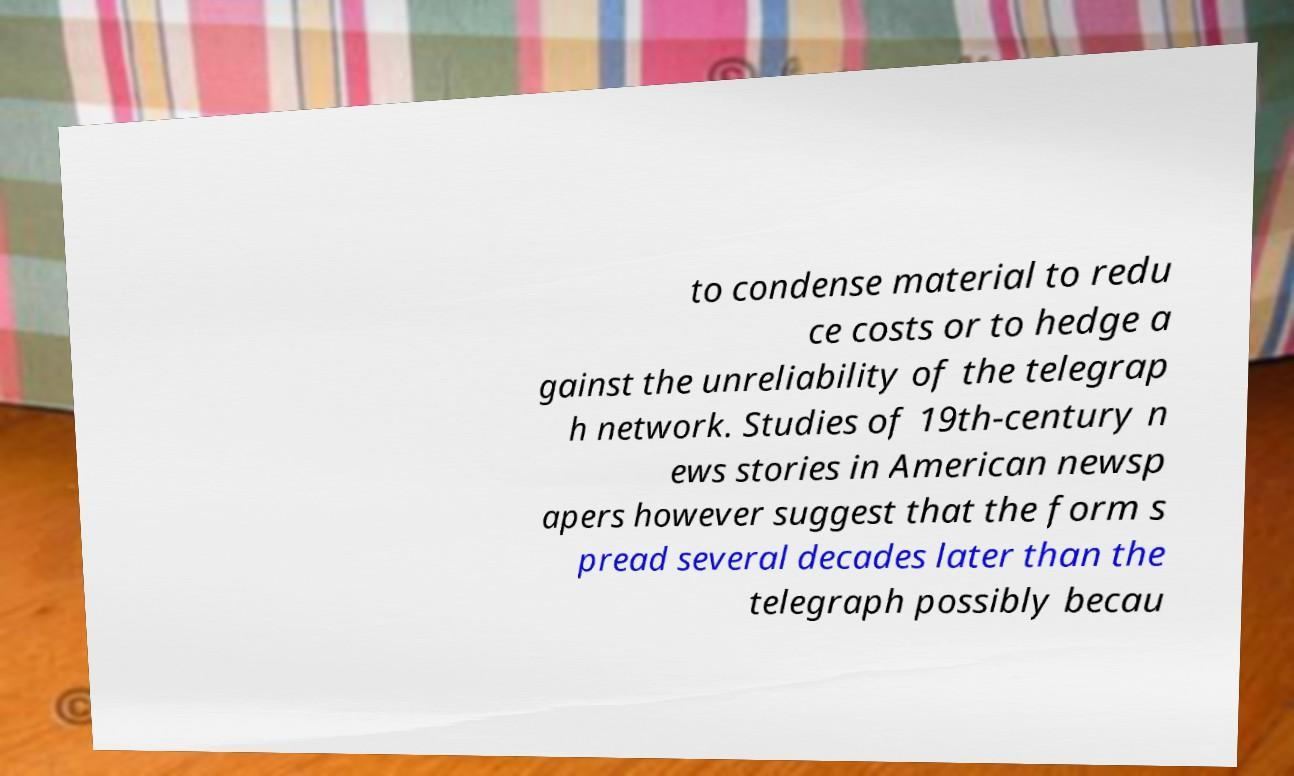For documentation purposes, I need the text within this image transcribed. Could you provide that? to condense material to redu ce costs or to hedge a gainst the unreliability of the telegrap h network. Studies of 19th-century n ews stories in American newsp apers however suggest that the form s pread several decades later than the telegraph possibly becau 